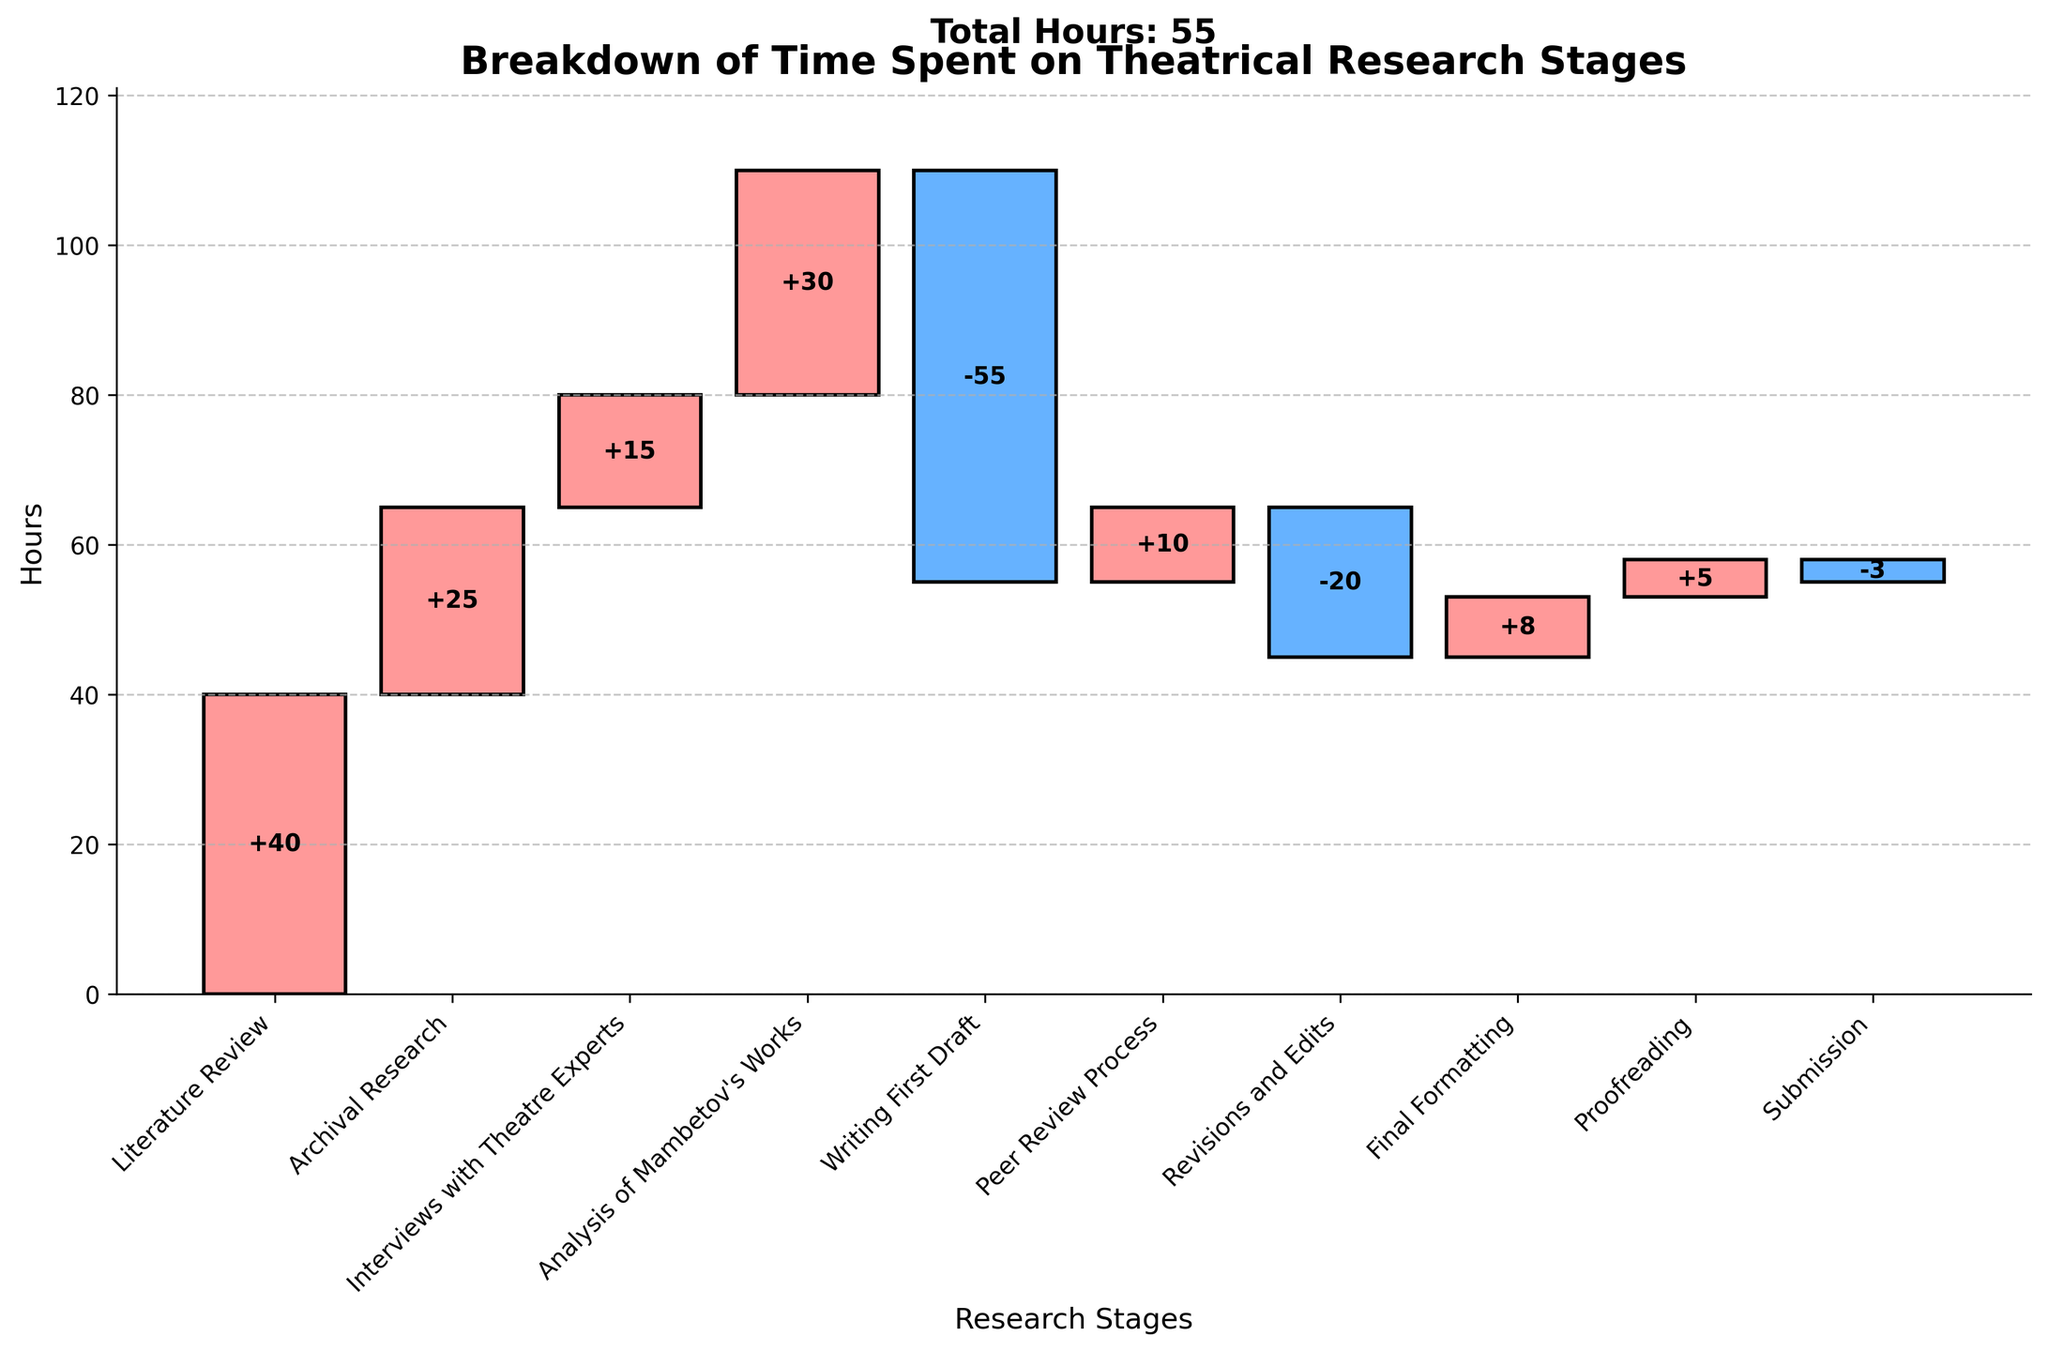What is the title of the chart? The title is located at the top of the chart and is clearly indicated. It summarizes the chart's purpose.
Answer: Breakdown of Time Spent on Theatrical Research Stages What is the y-axis label? The y-axis label is located along the vertical axis and denotes what is being measured.
Answer: Hours Which stage required the most time? By looking at the bars extending upwards the most, we can see that the Literature Review stage has the highest bar.
Answer: Literature Review How many hours were spent on Archival Research? Find the specific bar for Archival Research and look at the height or the label within the bar.
Answer: 25 What is the total time spent across all stages? The total time is given in the text at the top of the chart. It sums up all positive and negative hours.
Answer: 55 hours Which stage shows the largest decrease in hours? Examine the bars extending downwards to find the longest one, which represents the largest decrease.
Answer: Writing First Draft By how many hours does the Analysis of Mambetov's Works exceed the Peer Review Process? Subtract the hours spent on Peer Review Process (10) from the hours for Analysis of Mambetov's Works (30).
Answer: 20 hours Which stages have reduced the cumulative total of hours and by how much? Look for bars extending downwards: Writing First Draft (-55), Revisions and Edits (-20), and Submission (-3). Sum them up (-55 + (-20) + (-3)).
Answer: Writing First Draft (-55), Revisions and Edits (-20), Submission (-3); total reduction is 78 hours What is the cumulative time spent after completing Interviews with Theatre Experts? Sum up hours for Literature Review (40), Archival Research (25), and Interviews with Theatre Experts (15).
Answer: 80 hours Which research stages took less than 10 hours and can you list them? Identify bars smaller than 10 hours: Peer Review Process (10), Final Formatting (8), Proofreading (5), and Submission (-3), considering negative values if specified.
Answer: Final Formatting (8), Proofreading (5), Submission (-3) What stage is the final stage before submission and how much time was spent on it? Look at the staging order. The stage right before Submission is Proofreading. The corresponding bar shows the hours spent.
Answer: Proofreading; 5 hours 